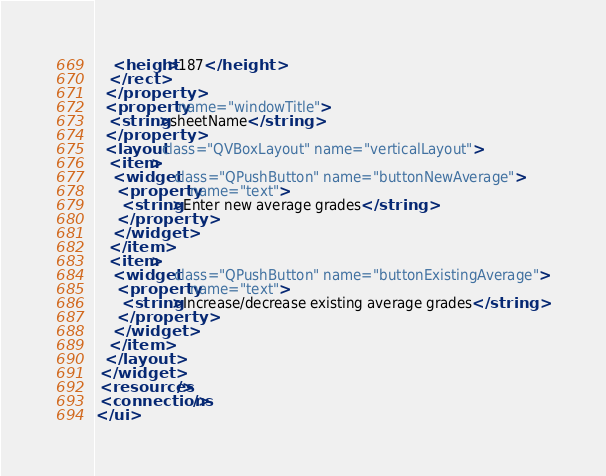<code> <loc_0><loc_0><loc_500><loc_500><_XML_>    <height>187</height>
   </rect>
  </property>
  <property name="windowTitle">
   <string>sheetName</string>
  </property>
  <layout class="QVBoxLayout" name="verticalLayout">
   <item>
    <widget class="QPushButton" name="buttonNewAverage">
     <property name="text">
      <string>Enter new average grades</string>
     </property>
    </widget>
   </item>
   <item>
    <widget class="QPushButton" name="buttonExistingAverage">
     <property name="text">
      <string>Increase/decrease existing average grades</string>
     </property>
    </widget>
   </item>
  </layout>
 </widget>
 <resources/>
 <connections/>
</ui>
</code> 